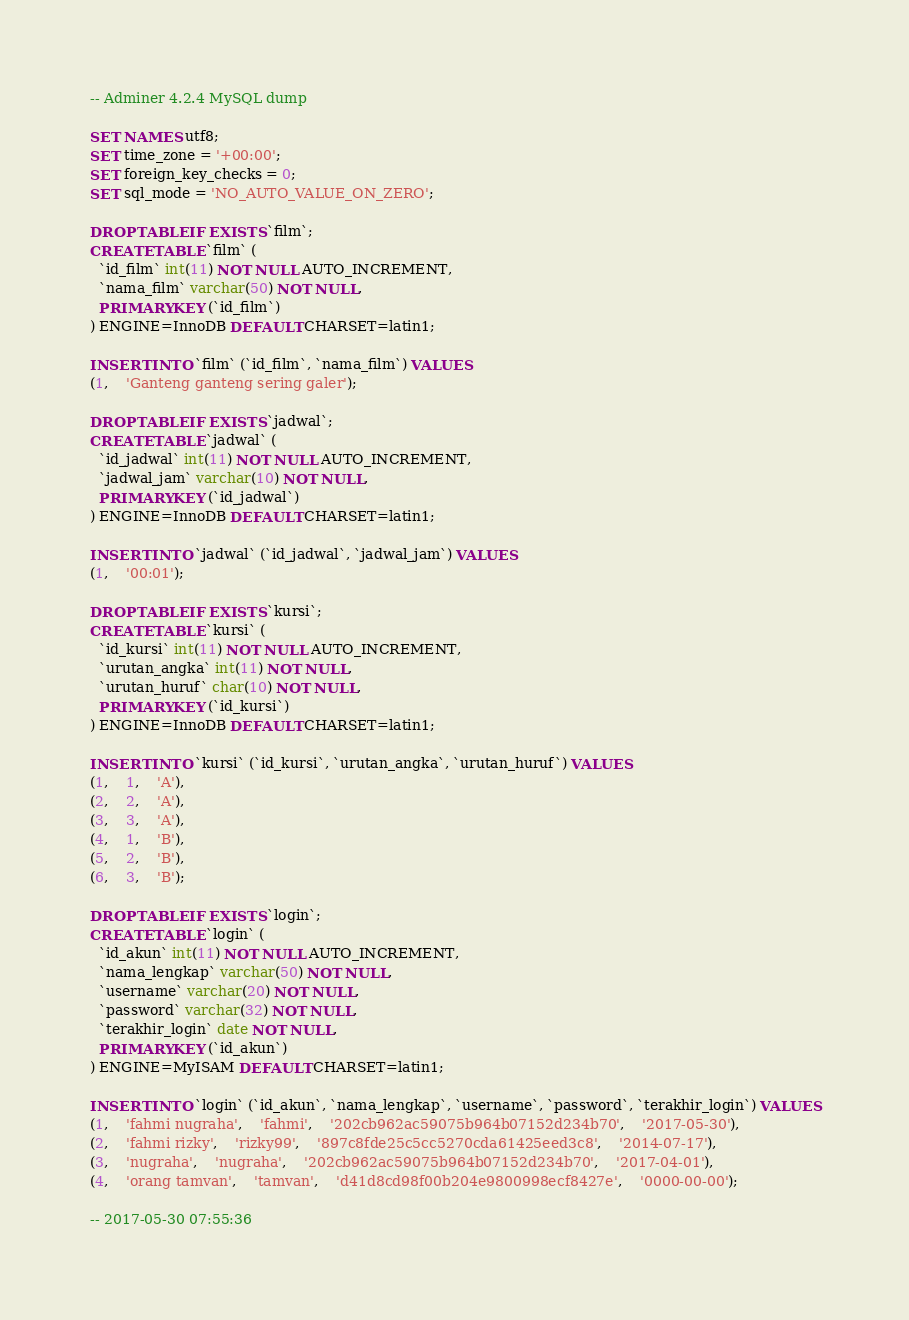Convert code to text. <code><loc_0><loc_0><loc_500><loc_500><_SQL_>-- Adminer 4.2.4 MySQL dump

SET NAMES utf8;
SET time_zone = '+00:00';
SET foreign_key_checks = 0;
SET sql_mode = 'NO_AUTO_VALUE_ON_ZERO';

DROP TABLE IF EXISTS `film`;
CREATE TABLE `film` (
  `id_film` int(11) NOT NULL AUTO_INCREMENT,
  `nama_film` varchar(50) NOT NULL,
  PRIMARY KEY (`id_film`)
) ENGINE=InnoDB DEFAULT CHARSET=latin1;

INSERT INTO `film` (`id_film`, `nama_film`) VALUES
(1,	'Ganteng ganteng sering galer');

DROP TABLE IF EXISTS `jadwal`;
CREATE TABLE `jadwal` (
  `id_jadwal` int(11) NOT NULL AUTO_INCREMENT,
  `jadwal_jam` varchar(10) NOT NULL,
  PRIMARY KEY (`id_jadwal`)
) ENGINE=InnoDB DEFAULT CHARSET=latin1;

INSERT INTO `jadwal` (`id_jadwal`, `jadwal_jam`) VALUES
(1,	'00:01');

DROP TABLE IF EXISTS `kursi`;
CREATE TABLE `kursi` (
  `id_kursi` int(11) NOT NULL AUTO_INCREMENT,
  `urutan_angka` int(11) NOT NULL,
  `urutan_huruf` char(10) NOT NULL,
  PRIMARY KEY (`id_kursi`)
) ENGINE=InnoDB DEFAULT CHARSET=latin1;

INSERT INTO `kursi` (`id_kursi`, `urutan_angka`, `urutan_huruf`) VALUES
(1,	1,	'A'),
(2,	2,	'A'),
(3,	3,	'A'),
(4,	1,	'B'),
(5,	2,	'B'),
(6,	3,	'B');

DROP TABLE IF EXISTS `login`;
CREATE TABLE `login` (
  `id_akun` int(11) NOT NULL AUTO_INCREMENT,
  `nama_lengkap` varchar(50) NOT NULL,
  `username` varchar(20) NOT NULL,
  `password` varchar(32) NOT NULL,
  `terakhir_login` date NOT NULL,
  PRIMARY KEY (`id_akun`)
) ENGINE=MyISAM DEFAULT CHARSET=latin1;

INSERT INTO `login` (`id_akun`, `nama_lengkap`, `username`, `password`, `terakhir_login`) VALUES
(1,	'fahmi nugraha',	'fahmi',	'202cb962ac59075b964b07152d234b70',	'2017-05-30'),
(2,	'fahmi rizky',	'rizky99',	'897c8fde25c5cc5270cda61425eed3c8',	'2014-07-17'),
(3,	'nugraha',	'nugraha',	'202cb962ac59075b964b07152d234b70',	'2017-04-01'),
(4,	'orang tamvan',	'tamvan',	'd41d8cd98f00b204e9800998ecf8427e',	'0000-00-00');

-- 2017-05-30 07:55:36
</code> 